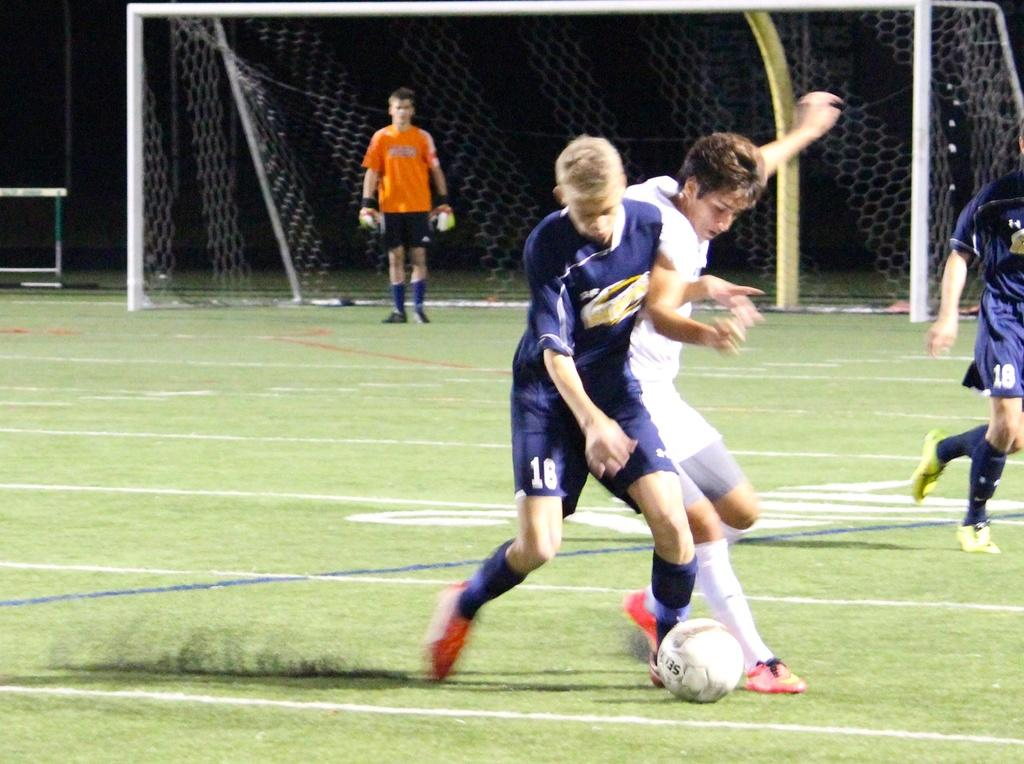What activity are the people in the image engaged in? The people in the image are playing with a ball. Where are the people playing with the ball? The people are on a ground. Can you describe the background of the image? In the background of the image, there is a man standing at a net. What type of voice can be heard coming from the beast in the image? There is no beast present in the image, so it is not possible to determine what type of voice might be heard. 